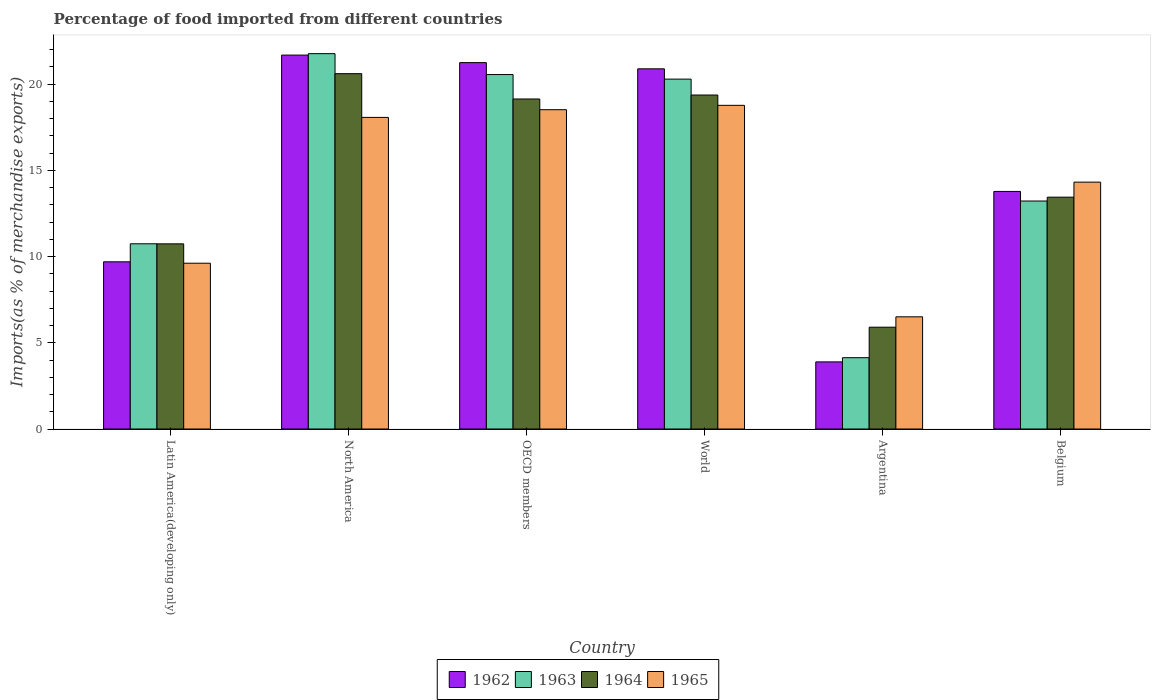How many bars are there on the 6th tick from the left?
Ensure brevity in your answer.  4. What is the label of the 1st group of bars from the left?
Offer a very short reply. Latin America(developing only). What is the percentage of imports to different countries in 1962 in Latin America(developing only)?
Your response must be concise. 9.7. Across all countries, what is the maximum percentage of imports to different countries in 1962?
Make the answer very short. 21.69. Across all countries, what is the minimum percentage of imports to different countries in 1964?
Offer a terse response. 5.91. In which country was the percentage of imports to different countries in 1962 maximum?
Ensure brevity in your answer.  North America. What is the total percentage of imports to different countries in 1962 in the graph?
Ensure brevity in your answer.  91.2. What is the difference between the percentage of imports to different countries in 1963 in Argentina and that in Belgium?
Give a very brief answer. -9.09. What is the difference between the percentage of imports to different countries in 1965 in Belgium and the percentage of imports to different countries in 1964 in North America?
Ensure brevity in your answer.  -6.29. What is the average percentage of imports to different countries in 1964 per country?
Keep it short and to the point. 14.87. What is the difference between the percentage of imports to different countries of/in 1963 and percentage of imports to different countries of/in 1964 in World?
Make the answer very short. 0.92. What is the ratio of the percentage of imports to different countries in 1964 in Belgium to that in OECD members?
Ensure brevity in your answer.  0.7. Is the percentage of imports to different countries in 1964 in Belgium less than that in OECD members?
Keep it short and to the point. Yes. What is the difference between the highest and the second highest percentage of imports to different countries in 1963?
Your answer should be compact. -0.26. What is the difference between the highest and the lowest percentage of imports to different countries in 1962?
Your answer should be very brief. 17.79. In how many countries, is the percentage of imports to different countries in 1964 greater than the average percentage of imports to different countries in 1964 taken over all countries?
Provide a succinct answer. 3. Is the sum of the percentage of imports to different countries in 1964 in Argentina and North America greater than the maximum percentage of imports to different countries in 1963 across all countries?
Give a very brief answer. Yes. What does the 4th bar from the left in Argentina represents?
Provide a succinct answer. 1965. What does the 1st bar from the right in Latin America(developing only) represents?
Provide a succinct answer. 1965. Is it the case that in every country, the sum of the percentage of imports to different countries in 1962 and percentage of imports to different countries in 1965 is greater than the percentage of imports to different countries in 1964?
Your response must be concise. Yes. How many countries are there in the graph?
Provide a short and direct response. 6. What is the difference between two consecutive major ticks on the Y-axis?
Make the answer very short. 5. Does the graph contain grids?
Ensure brevity in your answer.  No. How many legend labels are there?
Give a very brief answer. 4. How are the legend labels stacked?
Ensure brevity in your answer.  Horizontal. What is the title of the graph?
Provide a short and direct response. Percentage of food imported from different countries. What is the label or title of the Y-axis?
Your answer should be very brief. Imports(as % of merchandise exports). What is the Imports(as % of merchandise exports) of 1962 in Latin America(developing only)?
Make the answer very short. 9.7. What is the Imports(as % of merchandise exports) in 1963 in Latin America(developing only)?
Provide a short and direct response. 10.74. What is the Imports(as % of merchandise exports) of 1964 in Latin America(developing only)?
Offer a very short reply. 10.74. What is the Imports(as % of merchandise exports) in 1965 in Latin America(developing only)?
Ensure brevity in your answer.  9.62. What is the Imports(as % of merchandise exports) in 1962 in North America?
Keep it short and to the point. 21.69. What is the Imports(as % of merchandise exports) in 1963 in North America?
Your response must be concise. 21.77. What is the Imports(as % of merchandise exports) in 1964 in North America?
Offer a very short reply. 20.61. What is the Imports(as % of merchandise exports) in 1965 in North America?
Give a very brief answer. 18.07. What is the Imports(as % of merchandise exports) in 1962 in OECD members?
Your response must be concise. 21.25. What is the Imports(as % of merchandise exports) in 1963 in OECD members?
Ensure brevity in your answer.  20.56. What is the Imports(as % of merchandise exports) in 1964 in OECD members?
Ensure brevity in your answer.  19.14. What is the Imports(as % of merchandise exports) in 1965 in OECD members?
Your answer should be compact. 18.52. What is the Imports(as % of merchandise exports) in 1962 in World?
Your answer should be compact. 20.89. What is the Imports(as % of merchandise exports) in 1963 in World?
Keep it short and to the point. 20.29. What is the Imports(as % of merchandise exports) in 1964 in World?
Keep it short and to the point. 19.37. What is the Imports(as % of merchandise exports) in 1965 in World?
Offer a very short reply. 18.77. What is the Imports(as % of merchandise exports) of 1962 in Argentina?
Provide a short and direct response. 3.89. What is the Imports(as % of merchandise exports) of 1963 in Argentina?
Ensure brevity in your answer.  4.14. What is the Imports(as % of merchandise exports) of 1964 in Argentina?
Offer a very short reply. 5.91. What is the Imports(as % of merchandise exports) in 1965 in Argentina?
Keep it short and to the point. 6.51. What is the Imports(as % of merchandise exports) in 1962 in Belgium?
Keep it short and to the point. 13.78. What is the Imports(as % of merchandise exports) in 1963 in Belgium?
Provide a short and direct response. 13.22. What is the Imports(as % of merchandise exports) in 1964 in Belgium?
Your response must be concise. 13.45. What is the Imports(as % of merchandise exports) in 1965 in Belgium?
Provide a succinct answer. 14.32. Across all countries, what is the maximum Imports(as % of merchandise exports) in 1962?
Offer a terse response. 21.69. Across all countries, what is the maximum Imports(as % of merchandise exports) of 1963?
Offer a very short reply. 21.77. Across all countries, what is the maximum Imports(as % of merchandise exports) in 1964?
Your response must be concise. 20.61. Across all countries, what is the maximum Imports(as % of merchandise exports) in 1965?
Provide a succinct answer. 18.77. Across all countries, what is the minimum Imports(as % of merchandise exports) in 1962?
Offer a very short reply. 3.89. Across all countries, what is the minimum Imports(as % of merchandise exports) of 1963?
Provide a succinct answer. 4.14. Across all countries, what is the minimum Imports(as % of merchandise exports) of 1964?
Keep it short and to the point. 5.91. Across all countries, what is the minimum Imports(as % of merchandise exports) of 1965?
Provide a succinct answer. 6.51. What is the total Imports(as % of merchandise exports) of 1962 in the graph?
Offer a terse response. 91.2. What is the total Imports(as % of merchandise exports) of 1963 in the graph?
Keep it short and to the point. 90.73. What is the total Imports(as % of merchandise exports) of 1964 in the graph?
Your answer should be very brief. 89.21. What is the total Imports(as % of merchandise exports) of 1965 in the graph?
Provide a succinct answer. 85.81. What is the difference between the Imports(as % of merchandise exports) in 1962 in Latin America(developing only) and that in North America?
Provide a succinct answer. -11.99. What is the difference between the Imports(as % of merchandise exports) of 1963 in Latin America(developing only) and that in North America?
Offer a terse response. -11.03. What is the difference between the Imports(as % of merchandise exports) of 1964 in Latin America(developing only) and that in North America?
Keep it short and to the point. -9.87. What is the difference between the Imports(as % of merchandise exports) in 1965 in Latin America(developing only) and that in North America?
Provide a short and direct response. -8.46. What is the difference between the Imports(as % of merchandise exports) of 1962 in Latin America(developing only) and that in OECD members?
Ensure brevity in your answer.  -11.55. What is the difference between the Imports(as % of merchandise exports) of 1963 in Latin America(developing only) and that in OECD members?
Your answer should be very brief. -9.82. What is the difference between the Imports(as % of merchandise exports) in 1964 in Latin America(developing only) and that in OECD members?
Your answer should be very brief. -8.4. What is the difference between the Imports(as % of merchandise exports) of 1965 in Latin America(developing only) and that in OECD members?
Your response must be concise. -8.9. What is the difference between the Imports(as % of merchandise exports) of 1962 in Latin America(developing only) and that in World?
Make the answer very short. -11.19. What is the difference between the Imports(as % of merchandise exports) in 1963 in Latin America(developing only) and that in World?
Give a very brief answer. -9.55. What is the difference between the Imports(as % of merchandise exports) in 1964 in Latin America(developing only) and that in World?
Offer a very short reply. -8.63. What is the difference between the Imports(as % of merchandise exports) in 1965 in Latin America(developing only) and that in World?
Provide a short and direct response. -9.16. What is the difference between the Imports(as % of merchandise exports) in 1962 in Latin America(developing only) and that in Argentina?
Give a very brief answer. 5.8. What is the difference between the Imports(as % of merchandise exports) in 1963 in Latin America(developing only) and that in Argentina?
Your answer should be very brief. 6.61. What is the difference between the Imports(as % of merchandise exports) in 1964 in Latin America(developing only) and that in Argentina?
Offer a terse response. 4.83. What is the difference between the Imports(as % of merchandise exports) in 1965 in Latin America(developing only) and that in Argentina?
Provide a short and direct response. 3.11. What is the difference between the Imports(as % of merchandise exports) of 1962 in Latin America(developing only) and that in Belgium?
Keep it short and to the point. -4.08. What is the difference between the Imports(as % of merchandise exports) in 1963 in Latin America(developing only) and that in Belgium?
Keep it short and to the point. -2.48. What is the difference between the Imports(as % of merchandise exports) in 1964 in Latin America(developing only) and that in Belgium?
Offer a very short reply. -2.71. What is the difference between the Imports(as % of merchandise exports) in 1965 in Latin America(developing only) and that in Belgium?
Your answer should be very brief. -4.7. What is the difference between the Imports(as % of merchandise exports) in 1962 in North America and that in OECD members?
Ensure brevity in your answer.  0.44. What is the difference between the Imports(as % of merchandise exports) in 1963 in North America and that in OECD members?
Your answer should be compact. 1.21. What is the difference between the Imports(as % of merchandise exports) of 1964 in North America and that in OECD members?
Make the answer very short. 1.47. What is the difference between the Imports(as % of merchandise exports) of 1965 in North America and that in OECD members?
Provide a short and direct response. -0.45. What is the difference between the Imports(as % of merchandise exports) in 1962 in North America and that in World?
Make the answer very short. 0.8. What is the difference between the Imports(as % of merchandise exports) of 1963 in North America and that in World?
Provide a short and direct response. 1.48. What is the difference between the Imports(as % of merchandise exports) of 1964 in North America and that in World?
Provide a succinct answer. 1.24. What is the difference between the Imports(as % of merchandise exports) in 1965 in North America and that in World?
Keep it short and to the point. -0.7. What is the difference between the Imports(as % of merchandise exports) of 1962 in North America and that in Argentina?
Keep it short and to the point. 17.79. What is the difference between the Imports(as % of merchandise exports) in 1963 in North America and that in Argentina?
Your response must be concise. 17.63. What is the difference between the Imports(as % of merchandise exports) in 1964 in North America and that in Argentina?
Ensure brevity in your answer.  14.71. What is the difference between the Imports(as % of merchandise exports) of 1965 in North America and that in Argentina?
Offer a terse response. 11.57. What is the difference between the Imports(as % of merchandise exports) of 1962 in North America and that in Belgium?
Keep it short and to the point. 7.91. What is the difference between the Imports(as % of merchandise exports) of 1963 in North America and that in Belgium?
Your answer should be compact. 8.55. What is the difference between the Imports(as % of merchandise exports) of 1964 in North America and that in Belgium?
Provide a short and direct response. 7.16. What is the difference between the Imports(as % of merchandise exports) in 1965 in North America and that in Belgium?
Give a very brief answer. 3.75. What is the difference between the Imports(as % of merchandise exports) in 1962 in OECD members and that in World?
Offer a terse response. 0.36. What is the difference between the Imports(as % of merchandise exports) in 1963 in OECD members and that in World?
Provide a short and direct response. 0.26. What is the difference between the Imports(as % of merchandise exports) of 1964 in OECD members and that in World?
Ensure brevity in your answer.  -0.23. What is the difference between the Imports(as % of merchandise exports) in 1965 in OECD members and that in World?
Provide a short and direct response. -0.25. What is the difference between the Imports(as % of merchandise exports) of 1962 in OECD members and that in Argentina?
Provide a succinct answer. 17.36. What is the difference between the Imports(as % of merchandise exports) of 1963 in OECD members and that in Argentina?
Make the answer very short. 16.42. What is the difference between the Imports(as % of merchandise exports) in 1964 in OECD members and that in Argentina?
Your answer should be very brief. 13.24. What is the difference between the Imports(as % of merchandise exports) of 1965 in OECD members and that in Argentina?
Offer a terse response. 12.01. What is the difference between the Imports(as % of merchandise exports) in 1962 in OECD members and that in Belgium?
Provide a succinct answer. 7.47. What is the difference between the Imports(as % of merchandise exports) of 1963 in OECD members and that in Belgium?
Offer a terse response. 7.33. What is the difference between the Imports(as % of merchandise exports) in 1964 in OECD members and that in Belgium?
Ensure brevity in your answer.  5.7. What is the difference between the Imports(as % of merchandise exports) in 1965 in OECD members and that in Belgium?
Your answer should be very brief. 4.2. What is the difference between the Imports(as % of merchandise exports) of 1962 in World and that in Argentina?
Offer a very short reply. 17. What is the difference between the Imports(as % of merchandise exports) of 1963 in World and that in Argentina?
Your response must be concise. 16.16. What is the difference between the Imports(as % of merchandise exports) of 1964 in World and that in Argentina?
Your response must be concise. 13.47. What is the difference between the Imports(as % of merchandise exports) in 1965 in World and that in Argentina?
Your answer should be very brief. 12.27. What is the difference between the Imports(as % of merchandise exports) of 1962 in World and that in Belgium?
Your answer should be very brief. 7.11. What is the difference between the Imports(as % of merchandise exports) in 1963 in World and that in Belgium?
Your answer should be compact. 7.07. What is the difference between the Imports(as % of merchandise exports) of 1964 in World and that in Belgium?
Your response must be concise. 5.93. What is the difference between the Imports(as % of merchandise exports) of 1965 in World and that in Belgium?
Keep it short and to the point. 4.45. What is the difference between the Imports(as % of merchandise exports) of 1962 in Argentina and that in Belgium?
Your answer should be compact. -9.89. What is the difference between the Imports(as % of merchandise exports) of 1963 in Argentina and that in Belgium?
Make the answer very short. -9.09. What is the difference between the Imports(as % of merchandise exports) of 1964 in Argentina and that in Belgium?
Your response must be concise. -7.54. What is the difference between the Imports(as % of merchandise exports) of 1965 in Argentina and that in Belgium?
Keep it short and to the point. -7.81. What is the difference between the Imports(as % of merchandise exports) in 1962 in Latin America(developing only) and the Imports(as % of merchandise exports) in 1963 in North America?
Give a very brief answer. -12.07. What is the difference between the Imports(as % of merchandise exports) in 1962 in Latin America(developing only) and the Imports(as % of merchandise exports) in 1964 in North America?
Offer a very short reply. -10.91. What is the difference between the Imports(as % of merchandise exports) in 1962 in Latin America(developing only) and the Imports(as % of merchandise exports) in 1965 in North America?
Provide a succinct answer. -8.38. What is the difference between the Imports(as % of merchandise exports) in 1963 in Latin America(developing only) and the Imports(as % of merchandise exports) in 1964 in North America?
Your response must be concise. -9.87. What is the difference between the Imports(as % of merchandise exports) in 1963 in Latin America(developing only) and the Imports(as % of merchandise exports) in 1965 in North America?
Ensure brevity in your answer.  -7.33. What is the difference between the Imports(as % of merchandise exports) in 1964 in Latin America(developing only) and the Imports(as % of merchandise exports) in 1965 in North America?
Offer a terse response. -7.33. What is the difference between the Imports(as % of merchandise exports) in 1962 in Latin America(developing only) and the Imports(as % of merchandise exports) in 1963 in OECD members?
Offer a very short reply. -10.86. What is the difference between the Imports(as % of merchandise exports) in 1962 in Latin America(developing only) and the Imports(as % of merchandise exports) in 1964 in OECD members?
Offer a very short reply. -9.44. What is the difference between the Imports(as % of merchandise exports) of 1962 in Latin America(developing only) and the Imports(as % of merchandise exports) of 1965 in OECD members?
Provide a succinct answer. -8.82. What is the difference between the Imports(as % of merchandise exports) of 1963 in Latin America(developing only) and the Imports(as % of merchandise exports) of 1964 in OECD members?
Offer a very short reply. -8.4. What is the difference between the Imports(as % of merchandise exports) of 1963 in Latin America(developing only) and the Imports(as % of merchandise exports) of 1965 in OECD members?
Provide a short and direct response. -7.78. What is the difference between the Imports(as % of merchandise exports) in 1964 in Latin America(developing only) and the Imports(as % of merchandise exports) in 1965 in OECD members?
Offer a very short reply. -7.78. What is the difference between the Imports(as % of merchandise exports) in 1962 in Latin America(developing only) and the Imports(as % of merchandise exports) in 1963 in World?
Make the answer very short. -10.6. What is the difference between the Imports(as % of merchandise exports) of 1962 in Latin America(developing only) and the Imports(as % of merchandise exports) of 1964 in World?
Offer a very short reply. -9.67. What is the difference between the Imports(as % of merchandise exports) in 1962 in Latin America(developing only) and the Imports(as % of merchandise exports) in 1965 in World?
Make the answer very short. -9.08. What is the difference between the Imports(as % of merchandise exports) of 1963 in Latin America(developing only) and the Imports(as % of merchandise exports) of 1964 in World?
Offer a very short reply. -8.63. What is the difference between the Imports(as % of merchandise exports) in 1963 in Latin America(developing only) and the Imports(as % of merchandise exports) in 1965 in World?
Ensure brevity in your answer.  -8.03. What is the difference between the Imports(as % of merchandise exports) in 1964 in Latin America(developing only) and the Imports(as % of merchandise exports) in 1965 in World?
Offer a very short reply. -8.03. What is the difference between the Imports(as % of merchandise exports) of 1962 in Latin America(developing only) and the Imports(as % of merchandise exports) of 1963 in Argentina?
Give a very brief answer. 5.56. What is the difference between the Imports(as % of merchandise exports) in 1962 in Latin America(developing only) and the Imports(as % of merchandise exports) in 1964 in Argentina?
Make the answer very short. 3.79. What is the difference between the Imports(as % of merchandise exports) of 1962 in Latin America(developing only) and the Imports(as % of merchandise exports) of 1965 in Argentina?
Provide a short and direct response. 3.19. What is the difference between the Imports(as % of merchandise exports) of 1963 in Latin America(developing only) and the Imports(as % of merchandise exports) of 1964 in Argentina?
Your answer should be compact. 4.84. What is the difference between the Imports(as % of merchandise exports) in 1963 in Latin America(developing only) and the Imports(as % of merchandise exports) in 1965 in Argentina?
Make the answer very short. 4.24. What is the difference between the Imports(as % of merchandise exports) in 1964 in Latin America(developing only) and the Imports(as % of merchandise exports) in 1965 in Argentina?
Offer a terse response. 4.23. What is the difference between the Imports(as % of merchandise exports) of 1962 in Latin America(developing only) and the Imports(as % of merchandise exports) of 1963 in Belgium?
Your answer should be very brief. -3.53. What is the difference between the Imports(as % of merchandise exports) of 1962 in Latin America(developing only) and the Imports(as % of merchandise exports) of 1964 in Belgium?
Make the answer very short. -3.75. What is the difference between the Imports(as % of merchandise exports) of 1962 in Latin America(developing only) and the Imports(as % of merchandise exports) of 1965 in Belgium?
Your response must be concise. -4.62. What is the difference between the Imports(as % of merchandise exports) in 1963 in Latin America(developing only) and the Imports(as % of merchandise exports) in 1964 in Belgium?
Give a very brief answer. -2.7. What is the difference between the Imports(as % of merchandise exports) in 1963 in Latin America(developing only) and the Imports(as % of merchandise exports) in 1965 in Belgium?
Ensure brevity in your answer.  -3.58. What is the difference between the Imports(as % of merchandise exports) in 1964 in Latin America(developing only) and the Imports(as % of merchandise exports) in 1965 in Belgium?
Provide a succinct answer. -3.58. What is the difference between the Imports(as % of merchandise exports) in 1962 in North America and the Imports(as % of merchandise exports) in 1963 in OECD members?
Ensure brevity in your answer.  1.13. What is the difference between the Imports(as % of merchandise exports) of 1962 in North America and the Imports(as % of merchandise exports) of 1964 in OECD members?
Your answer should be very brief. 2.55. What is the difference between the Imports(as % of merchandise exports) of 1962 in North America and the Imports(as % of merchandise exports) of 1965 in OECD members?
Give a very brief answer. 3.17. What is the difference between the Imports(as % of merchandise exports) in 1963 in North America and the Imports(as % of merchandise exports) in 1964 in OECD members?
Provide a short and direct response. 2.63. What is the difference between the Imports(as % of merchandise exports) of 1963 in North America and the Imports(as % of merchandise exports) of 1965 in OECD members?
Provide a succinct answer. 3.25. What is the difference between the Imports(as % of merchandise exports) of 1964 in North America and the Imports(as % of merchandise exports) of 1965 in OECD members?
Provide a short and direct response. 2.09. What is the difference between the Imports(as % of merchandise exports) in 1962 in North America and the Imports(as % of merchandise exports) in 1963 in World?
Ensure brevity in your answer.  1.39. What is the difference between the Imports(as % of merchandise exports) in 1962 in North America and the Imports(as % of merchandise exports) in 1964 in World?
Make the answer very short. 2.32. What is the difference between the Imports(as % of merchandise exports) of 1962 in North America and the Imports(as % of merchandise exports) of 1965 in World?
Give a very brief answer. 2.91. What is the difference between the Imports(as % of merchandise exports) in 1963 in North America and the Imports(as % of merchandise exports) in 1964 in World?
Offer a terse response. 2.4. What is the difference between the Imports(as % of merchandise exports) of 1963 in North America and the Imports(as % of merchandise exports) of 1965 in World?
Provide a succinct answer. 3. What is the difference between the Imports(as % of merchandise exports) in 1964 in North America and the Imports(as % of merchandise exports) in 1965 in World?
Offer a terse response. 1.84. What is the difference between the Imports(as % of merchandise exports) of 1962 in North America and the Imports(as % of merchandise exports) of 1963 in Argentina?
Provide a succinct answer. 17.55. What is the difference between the Imports(as % of merchandise exports) of 1962 in North America and the Imports(as % of merchandise exports) of 1964 in Argentina?
Provide a succinct answer. 15.78. What is the difference between the Imports(as % of merchandise exports) of 1962 in North America and the Imports(as % of merchandise exports) of 1965 in Argentina?
Give a very brief answer. 15.18. What is the difference between the Imports(as % of merchandise exports) of 1963 in North America and the Imports(as % of merchandise exports) of 1964 in Argentina?
Make the answer very short. 15.87. What is the difference between the Imports(as % of merchandise exports) in 1963 in North America and the Imports(as % of merchandise exports) in 1965 in Argentina?
Give a very brief answer. 15.26. What is the difference between the Imports(as % of merchandise exports) in 1964 in North America and the Imports(as % of merchandise exports) in 1965 in Argentina?
Keep it short and to the point. 14.1. What is the difference between the Imports(as % of merchandise exports) in 1962 in North America and the Imports(as % of merchandise exports) in 1963 in Belgium?
Provide a short and direct response. 8.46. What is the difference between the Imports(as % of merchandise exports) in 1962 in North America and the Imports(as % of merchandise exports) in 1964 in Belgium?
Provide a short and direct response. 8.24. What is the difference between the Imports(as % of merchandise exports) of 1962 in North America and the Imports(as % of merchandise exports) of 1965 in Belgium?
Your answer should be very brief. 7.37. What is the difference between the Imports(as % of merchandise exports) of 1963 in North America and the Imports(as % of merchandise exports) of 1964 in Belgium?
Offer a very short reply. 8.33. What is the difference between the Imports(as % of merchandise exports) of 1963 in North America and the Imports(as % of merchandise exports) of 1965 in Belgium?
Provide a short and direct response. 7.45. What is the difference between the Imports(as % of merchandise exports) of 1964 in North America and the Imports(as % of merchandise exports) of 1965 in Belgium?
Provide a succinct answer. 6.29. What is the difference between the Imports(as % of merchandise exports) of 1962 in OECD members and the Imports(as % of merchandise exports) of 1963 in World?
Give a very brief answer. 0.96. What is the difference between the Imports(as % of merchandise exports) in 1962 in OECD members and the Imports(as % of merchandise exports) in 1964 in World?
Provide a succinct answer. 1.88. What is the difference between the Imports(as % of merchandise exports) of 1962 in OECD members and the Imports(as % of merchandise exports) of 1965 in World?
Make the answer very short. 2.48. What is the difference between the Imports(as % of merchandise exports) of 1963 in OECD members and the Imports(as % of merchandise exports) of 1964 in World?
Keep it short and to the point. 1.19. What is the difference between the Imports(as % of merchandise exports) in 1963 in OECD members and the Imports(as % of merchandise exports) in 1965 in World?
Your response must be concise. 1.78. What is the difference between the Imports(as % of merchandise exports) in 1964 in OECD members and the Imports(as % of merchandise exports) in 1965 in World?
Offer a terse response. 0.37. What is the difference between the Imports(as % of merchandise exports) in 1962 in OECD members and the Imports(as % of merchandise exports) in 1963 in Argentina?
Provide a short and direct response. 17.11. What is the difference between the Imports(as % of merchandise exports) of 1962 in OECD members and the Imports(as % of merchandise exports) of 1964 in Argentina?
Your answer should be very brief. 15.35. What is the difference between the Imports(as % of merchandise exports) of 1962 in OECD members and the Imports(as % of merchandise exports) of 1965 in Argentina?
Offer a very short reply. 14.74. What is the difference between the Imports(as % of merchandise exports) of 1963 in OECD members and the Imports(as % of merchandise exports) of 1964 in Argentina?
Provide a succinct answer. 14.65. What is the difference between the Imports(as % of merchandise exports) of 1963 in OECD members and the Imports(as % of merchandise exports) of 1965 in Argentina?
Your answer should be compact. 14.05. What is the difference between the Imports(as % of merchandise exports) of 1964 in OECD members and the Imports(as % of merchandise exports) of 1965 in Argentina?
Ensure brevity in your answer.  12.64. What is the difference between the Imports(as % of merchandise exports) in 1962 in OECD members and the Imports(as % of merchandise exports) in 1963 in Belgium?
Your response must be concise. 8.03. What is the difference between the Imports(as % of merchandise exports) in 1962 in OECD members and the Imports(as % of merchandise exports) in 1964 in Belgium?
Give a very brief answer. 7.81. What is the difference between the Imports(as % of merchandise exports) in 1962 in OECD members and the Imports(as % of merchandise exports) in 1965 in Belgium?
Provide a short and direct response. 6.93. What is the difference between the Imports(as % of merchandise exports) of 1963 in OECD members and the Imports(as % of merchandise exports) of 1964 in Belgium?
Offer a terse response. 7.11. What is the difference between the Imports(as % of merchandise exports) in 1963 in OECD members and the Imports(as % of merchandise exports) in 1965 in Belgium?
Offer a very short reply. 6.24. What is the difference between the Imports(as % of merchandise exports) in 1964 in OECD members and the Imports(as % of merchandise exports) in 1965 in Belgium?
Offer a terse response. 4.82. What is the difference between the Imports(as % of merchandise exports) in 1962 in World and the Imports(as % of merchandise exports) in 1963 in Argentina?
Provide a short and direct response. 16.75. What is the difference between the Imports(as % of merchandise exports) of 1962 in World and the Imports(as % of merchandise exports) of 1964 in Argentina?
Ensure brevity in your answer.  14.99. What is the difference between the Imports(as % of merchandise exports) of 1962 in World and the Imports(as % of merchandise exports) of 1965 in Argentina?
Offer a terse response. 14.38. What is the difference between the Imports(as % of merchandise exports) in 1963 in World and the Imports(as % of merchandise exports) in 1964 in Argentina?
Your response must be concise. 14.39. What is the difference between the Imports(as % of merchandise exports) in 1963 in World and the Imports(as % of merchandise exports) in 1965 in Argentina?
Offer a terse response. 13.79. What is the difference between the Imports(as % of merchandise exports) of 1964 in World and the Imports(as % of merchandise exports) of 1965 in Argentina?
Provide a short and direct response. 12.86. What is the difference between the Imports(as % of merchandise exports) in 1962 in World and the Imports(as % of merchandise exports) in 1963 in Belgium?
Your answer should be very brief. 7.67. What is the difference between the Imports(as % of merchandise exports) in 1962 in World and the Imports(as % of merchandise exports) in 1964 in Belgium?
Your answer should be compact. 7.44. What is the difference between the Imports(as % of merchandise exports) in 1962 in World and the Imports(as % of merchandise exports) in 1965 in Belgium?
Offer a very short reply. 6.57. What is the difference between the Imports(as % of merchandise exports) in 1963 in World and the Imports(as % of merchandise exports) in 1964 in Belgium?
Provide a short and direct response. 6.85. What is the difference between the Imports(as % of merchandise exports) of 1963 in World and the Imports(as % of merchandise exports) of 1965 in Belgium?
Your response must be concise. 5.97. What is the difference between the Imports(as % of merchandise exports) of 1964 in World and the Imports(as % of merchandise exports) of 1965 in Belgium?
Your response must be concise. 5.05. What is the difference between the Imports(as % of merchandise exports) in 1962 in Argentina and the Imports(as % of merchandise exports) in 1963 in Belgium?
Your response must be concise. -9.33. What is the difference between the Imports(as % of merchandise exports) of 1962 in Argentina and the Imports(as % of merchandise exports) of 1964 in Belgium?
Your response must be concise. -9.55. What is the difference between the Imports(as % of merchandise exports) in 1962 in Argentina and the Imports(as % of merchandise exports) in 1965 in Belgium?
Offer a terse response. -10.43. What is the difference between the Imports(as % of merchandise exports) of 1963 in Argentina and the Imports(as % of merchandise exports) of 1964 in Belgium?
Provide a short and direct response. -9.31. What is the difference between the Imports(as % of merchandise exports) in 1963 in Argentina and the Imports(as % of merchandise exports) in 1965 in Belgium?
Provide a succinct answer. -10.18. What is the difference between the Imports(as % of merchandise exports) of 1964 in Argentina and the Imports(as % of merchandise exports) of 1965 in Belgium?
Ensure brevity in your answer.  -8.41. What is the average Imports(as % of merchandise exports) of 1963 per country?
Keep it short and to the point. 15.12. What is the average Imports(as % of merchandise exports) in 1964 per country?
Provide a short and direct response. 14.87. What is the average Imports(as % of merchandise exports) of 1965 per country?
Keep it short and to the point. 14.3. What is the difference between the Imports(as % of merchandise exports) of 1962 and Imports(as % of merchandise exports) of 1963 in Latin America(developing only)?
Make the answer very short. -1.05. What is the difference between the Imports(as % of merchandise exports) in 1962 and Imports(as % of merchandise exports) in 1964 in Latin America(developing only)?
Offer a terse response. -1.04. What is the difference between the Imports(as % of merchandise exports) in 1962 and Imports(as % of merchandise exports) in 1965 in Latin America(developing only)?
Give a very brief answer. 0.08. What is the difference between the Imports(as % of merchandise exports) in 1963 and Imports(as % of merchandise exports) in 1964 in Latin America(developing only)?
Your answer should be very brief. 0. What is the difference between the Imports(as % of merchandise exports) of 1963 and Imports(as % of merchandise exports) of 1965 in Latin America(developing only)?
Your answer should be very brief. 1.13. What is the difference between the Imports(as % of merchandise exports) of 1964 and Imports(as % of merchandise exports) of 1965 in Latin America(developing only)?
Keep it short and to the point. 1.12. What is the difference between the Imports(as % of merchandise exports) of 1962 and Imports(as % of merchandise exports) of 1963 in North America?
Offer a terse response. -0.08. What is the difference between the Imports(as % of merchandise exports) of 1962 and Imports(as % of merchandise exports) of 1964 in North America?
Make the answer very short. 1.08. What is the difference between the Imports(as % of merchandise exports) in 1962 and Imports(as % of merchandise exports) in 1965 in North America?
Your answer should be very brief. 3.61. What is the difference between the Imports(as % of merchandise exports) of 1963 and Imports(as % of merchandise exports) of 1964 in North America?
Provide a succinct answer. 1.16. What is the difference between the Imports(as % of merchandise exports) in 1963 and Imports(as % of merchandise exports) in 1965 in North America?
Offer a terse response. 3.7. What is the difference between the Imports(as % of merchandise exports) of 1964 and Imports(as % of merchandise exports) of 1965 in North America?
Keep it short and to the point. 2.54. What is the difference between the Imports(as % of merchandise exports) in 1962 and Imports(as % of merchandise exports) in 1963 in OECD members?
Provide a short and direct response. 0.69. What is the difference between the Imports(as % of merchandise exports) of 1962 and Imports(as % of merchandise exports) of 1964 in OECD members?
Offer a terse response. 2.11. What is the difference between the Imports(as % of merchandise exports) in 1962 and Imports(as % of merchandise exports) in 1965 in OECD members?
Your answer should be compact. 2.73. What is the difference between the Imports(as % of merchandise exports) of 1963 and Imports(as % of merchandise exports) of 1964 in OECD members?
Make the answer very short. 1.42. What is the difference between the Imports(as % of merchandise exports) of 1963 and Imports(as % of merchandise exports) of 1965 in OECD members?
Provide a succinct answer. 2.04. What is the difference between the Imports(as % of merchandise exports) of 1964 and Imports(as % of merchandise exports) of 1965 in OECD members?
Ensure brevity in your answer.  0.62. What is the difference between the Imports(as % of merchandise exports) of 1962 and Imports(as % of merchandise exports) of 1963 in World?
Ensure brevity in your answer.  0.6. What is the difference between the Imports(as % of merchandise exports) in 1962 and Imports(as % of merchandise exports) in 1964 in World?
Provide a short and direct response. 1.52. What is the difference between the Imports(as % of merchandise exports) in 1962 and Imports(as % of merchandise exports) in 1965 in World?
Provide a succinct answer. 2.12. What is the difference between the Imports(as % of merchandise exports) of 1963 and Imports(as % of merchandise exports) of 1964 in World?
Your answer should be very brief. 0.92. What is the difference between the Imports(as % of merchandise exports) of 1963 and Imports(as % of merchandise exports) of 1965 in World?
Keep it short and to the point. 1.52. What is the difference between the Imports(as % of merchandise exports) in 1964 and Imports(as % of merchandise exports) in 1965 in World?
Make the answer very short. 0.6. What is the difference between the Imports(as % of merchandise exports) of 1962 and Imports(as % of merchandise exports) of 1963 in Argentina?
Give a very brief answer. -0.24. What is the difference between the Imports(as % of merchandise exports) in 1962 and Imports(as % of merchandise exports) in 1964 in Argentina?
Keep it short and to the point. -2.01. What is the difference between the Imports(as % of merchandise exports) of 1962 and Imports(as % of merchandise exports) of 1965 in Argentina?
Your answer should be compact. -2.61. What is the difference between the Imports(as % of merchandise exports) in 1963 and Imports(as % of merchandise exports) in 1964 in Argentina?
Give a very brief answer. -1.77. What is the difference between the Imports(as % of merchandise exports) of 1963 and Imports(as % of merchandise exports) of 1965 in Argentina?
Give a very brief answer. -2.37. What is the difference between the Imports(as % of merchandise exports) in 1964 and Imports(as % of merchandise exports) in 1965 in Argentina?
Ensure brevity in your answer.  -0.6. What is the difference between the Imports(as % of merchandise exports) in 1962 and Imports(as % of merchandise exports) in 1963 in Belgium?
Your answer should be compact. 0.56. What is the difference between the Imports(as % of merchandise exports) in 1962 and Imports(as % of merchandise exports) in 1964 in Belgium?
Your response must be concise. 0.33. What is the difference between the Imports(as % of merchandise exports) of 1962 and Imports(as % of merchandise exports) of 1965 in Belgium?
Ensure brevity in your answer.  -0.54. What is the difference between the Imports(as % of merchandise exports) in 1963 and Imports(as % of merchandise exports) in 1964 in Belgium?
Your answer should be compact. -0.22. What is the difference between the Imports(as % of merchandise exports) in 1963 and Imports(as % of merchandise exports) in 1965 in Belgium?
Provide a short and direct response. -1.1. What is the difference between the Imports(as % of merchandise exports) of 1964 and Imports(as % of merchandise exports) of 1965 in Belgium?
Give a very brief answer. -0.87. What is the ratio of the Imports(as % of merchandise exports) of 1962 in Latin America(developing only) to that in North America?
Your response must be concise. 0.45. What is the ratio of the Imports(as % of merchandise exports) in 1963 in Latin America(developing only) to that in North America?
Your response must be concise. 0.49. What is the ratio of the Imports(as % of merchandise exports) in 1964 in Latin America(developing only) to that in North America?
Provide a succinct answer. 0.52. What is the ratio of the Imports(as % of merchandise exports) in 1965 in Latin America(developing only) to that in North America?
Offer a terse response. 0.53. What is the ratio of the Imports(as % of merchandise exports) in 1962 in Latin America(developing only) to that in OECD members?
Offer a very short reply. 0.46. What is the ratio of the Imports(as % of merchandise exports) of 1963 in Latin America(developing only) to that in OECD members?
Keep it short and to the point. 0.52. What is the ratio of the Imports(as % of merchandise exports) of 1964 in Latin America(developing only) to that in OECD members?
Offer a terse response. 0.56. What is the ratio of the Imports(as % of merchandise exports) in 1965 in Latin America(developing only) to that in OECD members?
Your answer should be compact. 0.52. What is the ratio of the Imports(as % of merchandise exports) in 1962 in Latin America(developing only) to that in World?
Your answer should be very brief. 0.46. What is the ratio of the Imports(as % of merchandise exports) in 1963 in Latin America(developing only) to that in World?
Keep it short and to the point. 0.53. What is the ratio of the Imports(as % of merchandise exports) of 1964 in Latin America(developing only) to that in World?
Your answer should be very brief. 0.55. What is the ratio of the Imports(as % of merchandise exports) in 1965 in Latin America(developing only) to that in World?
Your response must be concise. 0.51. What is the ratio of the Imports(as % of merchandise exports) of 1962 in Latin America(developing only) to that in Argentina?
Provide a succinct answer. 2.49. What is the ratio of the Imports(as % of merchandise exports) in 1963 in Latin America(developing only) to that in Argentina?
Make the answer very short. 2.6. What is the ratio of the Imports(as % of merchandise exports) of 1964 in Latin America(developing only) to that in Argentina?
Your answer should be compact. 1.82. What is the ratio of the Imports(as % of merchandise exports) of 1965 in Latin America(developing only) to that in Argentina?
Offer a very short reply. 1.48. What is the ratio of the Imports(as % of merchandise exports) in 1962 in Latin America(developing only) to that in Belgium?
Provide a short and direct response. 0.7. What is the ratio of the Imports(as % of merchandise exports) in 1963 in Latin America(developing only) to that in Belgium?
Make the answer very short. 0.81. What is the ratio of the Imports(as % of merchandise exports) of 1964 in Latin America(developing only) to that in Belgium?
Offer a terse response. 0.8. What is the ratio of the Imports(as % of merchandise exports) of 1965 in Latin America(developing only) to that in Belgium?
Provide a short and direct response. 0.67. What is the ratio of the Imports(as % of merchandise exports) of 1962 in North America to that in OECD members?
Your answer should be very brief. 1.02. What is the ratio of the Imports(as % of merchandise exports) in 1963 in North America to that in OECD members?
Your response must be concise. 1.06. What is the ratio of the Imports(as % of merchandise exports) in 1964 in North America to that in OECD members?
Offer a terse response. 1.08. What is the ratio of the Imports(as % of merchandise exports) of 1965 in North America to that in OECD members?
Keep it short and to the point. 0.98. What is the ratio of the Imports(as % of merchandise exports) of 1962 in North America to that in World?
Ensure brevity in your answer.  1.04. What is the ratio of the Imports(as % of merchandise exports) in 1963 in North America to that in World?
Your answer should be very brief. 1.07. What is the ratio of the Imports(as % of merchandise exports) of 1964 in North America to that in World?
Give a very brief answer. 1.06. What is the ratio of the Imports(as % of merchandise exports) in 1965 in North America to that in World?
Your answer should be very brief. 0.96. What is the ratio of the Imports(as % of merchandise exports) in 1962 in North America to that in Argentina?
Give a very brief answer. 5.57. What is the ratio of the Imports(as % of merchandise exports) of 1963 in North America to that in Argentina?
Offer a terse response. 5.26. What is the ratio of the Imports(as % of merchandise exports) in 1964 in North America to that in Argentina?
Your answer should be very brief. 3.49. What is the ratio of the Imports(as % of merchandise exports) of 1965 in North America to that in Argentina?
Offer a very short reply. 2.78. What is the ratio of the Imports(as % of merchandise exports) of 1962 in North America to that in Belgium?
Your answer should be very brief. 1.57. What is the ratio of the Imports(as % of merchandise exports) in 1963 in North America to that in Belgium?
Your response must be concise. 1.65. What is the ratio of the Imports(as % of merchandise exports) of 1964 in North America to that in Belgium?
Your response must be concise. 1.53. What is the ratio of the Imports(as % of merchandise exports) in 1965 in North America to that in Belgium?
Offer a very short reply. 1.26. What is the ratio of the Imports(as % of merchandise exports) in 1962 in OECD members to that in World?
Your answer should be very brief. 1.02. What is the ratio of the Imports(as % of merchandise exports) of 1965 in OECD members to that in World?
Make the answer very short. 0.99. What is the ratio of the Imports(as % of merchandise exports) of 1962 in OECD members to that in Argentina?
Ensure brevity in your answer.  5.46. What is the ratio of the Imports(as % of merchandise exports) of 1963 in OECD members to that in Argentina?
Your answer should be very brief. 4.97. What is the ratio of the Imports(as % of merchandise exports) in 1964 in OECD members to that in Argentina?
Your answer should be compact. 3.24. What is the ratio of the Imports(as % of merchandise exports) of 1965 in OECD members to that in Argentina?
Make the answer very short. 2.85. What is the ratio of the Imports(as % of merchandise exports) of 1962 in OECD members to that in Belgium?
Ensure brevity in your answer.  1.54. What is the ratio of the Imports(as % of merchandise exports) of 1963 in OECD members to that in Belgium?
Give a very brief answer. 1.55. What is the ratio of the Imports(as % of merchandise exports) in 1964 in OECD members to that in Belgium?
Your response must be concise. 1.42. What is the ratio of the Imports(as % of merchandise exports) of 1965 in OECD members to that in Belgium?
Provide a short and direct response. 1.29. What is the ratio of the Imports(as % of merchandise exports) of 1962 in World to that in Argentina?
Your answer should be compact. 5.37. What is the ratio of the Imports(as % of merchandise exports) in 1963 in World to that in Argentina?
Provide a succinct answer. 4.91. What is the ratio of the Imports(as % of merchandise exports) of 1964 in World to that in Argentina?
Give a very brief answer. 3.28. What is the ratio of the Imports(as % of merchandise exports) of 1965 in World to that in Argentina?
Provide a succinct answer. 2.89. What is the ratio of the Imports(as % of merchandise exports) in 1962 in World to that in Belgium?
Give a very brief answer. 1.52. What is the ratio of the Imports(as % of merchandise exports) of 1963 in World to that in Belgium?
Provide a succinct answer. 1.53. What is the ratio of the Imports(as % of merchandise exports) of 1964 in World to that in Belgium?
Give a very brief answer. 1.44. What is the ratio of the Imports(as % of merchandise exports) in 1965 in World to that in Belgium?
Give a very brief answer. 1.31. What is the ratio of the Imports(as % of merchandise exports) of 1962 in Argentina to that in Belgium?
Your response must be concise. 0.28. What is the ratio of the Imports(as % of merchandise exports) of 1963 in Argentina to that in Belgium?
Give a very brief answer. 0.31. What is the ratio of the Imports(as % of merchandise exports) of 1964 in Argentina to that in Belgium?
Your answer should be compact. 0.44. What is the ratio of the Imports(as % of merchandise exports) of 1965 in Argentina to that in Belgium?
Give a very brief answer. 0.45. What is the difference between the highest and the second highest Imports(as % of merchandise exports) in 1962?
Make the answer very short. 0.44. What is the difference between the highest and the second highest Imports(as % of merchandise exports) in 1963?
Offer a terse response. 1.21. What is the difference between the highest and the second highest Imports(as % of merchandise exports) of 1964?
Your answer should be very brief. 1.24. What is the difference between the highest and the second highest Imports(as % of merchandise exports) of 1965?
Keep it short and to the point. 0.25. What is the difference between the highest and the lowest Imports(as % of merchandise exports) of 1962?
Give a very brief answer. 17.79. What is the difference between the highest and the lowest Imports(as % of merchandise exports) in 1963?
Offer a very short reply. 17.63. What is the difference between the highest and the lowest Imports(as % of merchandise exports) in 1964?
Offer a terse response. 14.71. What is the difference between the highest and the lowest Imports(as % of merchandise exports) of 1965?
Ensure brevity in your answer.  12.27. 